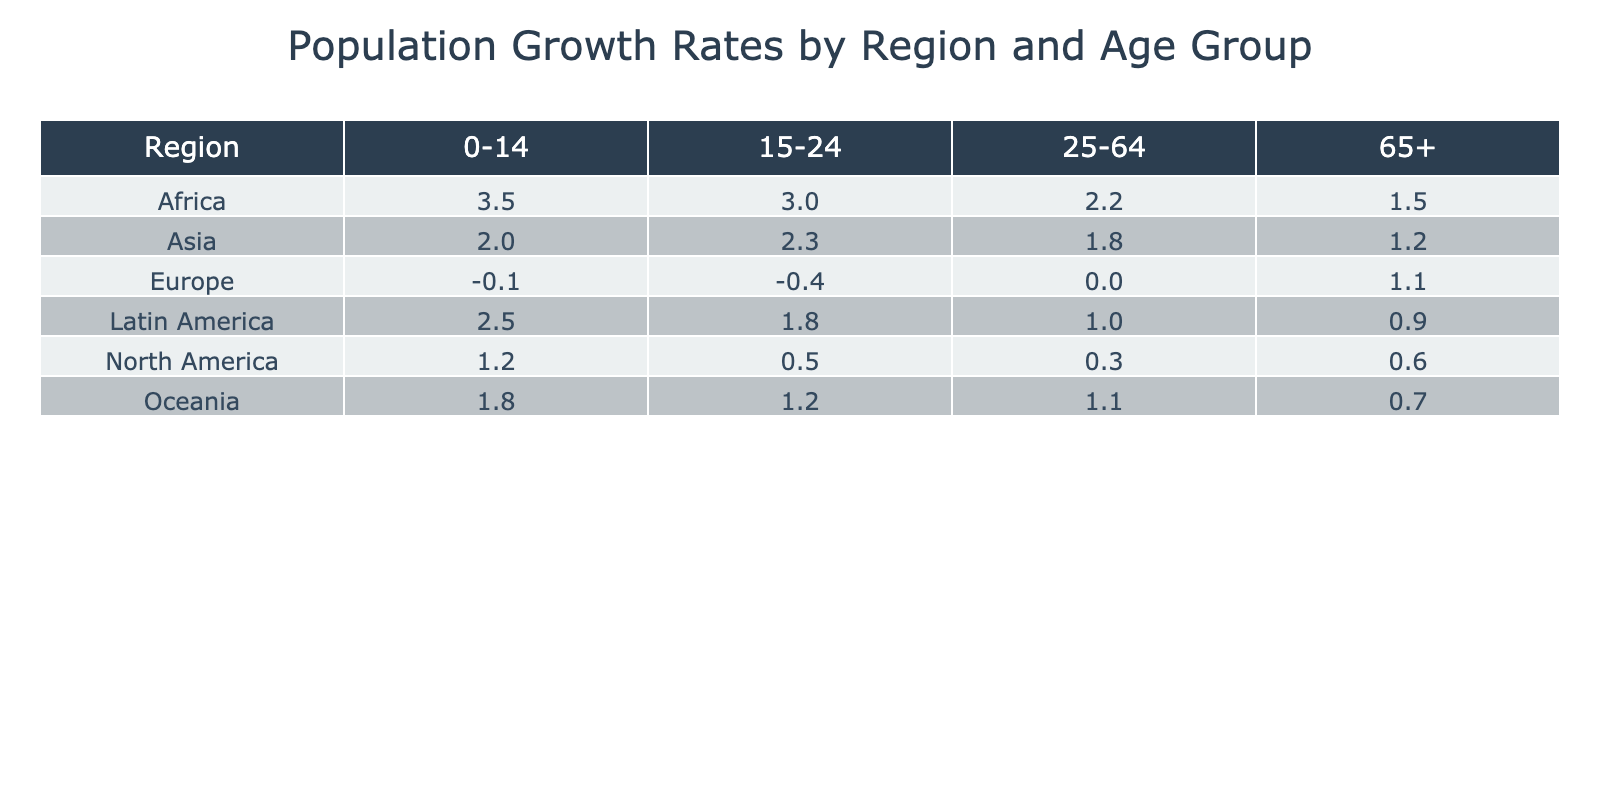What is the population growth rate for the age group 25-64 in North America? From the table, under the region North America and the age group 25-64, the corresponding value is 0.3%.
Answer: 0.3% Which region has the highest population growth rate for the age group 0-14? In the table, when checking the values for the age group 0-14, Africa has the highest rate at 3.5%.
Answer: Africa Is the population growth rate for the age group 65+ in Europe positive? Looking at the age group 65+ for Europe in the table, the value is 1.1%, which is indeed positive.
Answer: Yes What is the average population growth rate for the age group 15-24 across all regions? We first find the values for each region in the 15-24 age group: North America (0.5%), Latin America (1.8%), Europe (-0.4%), Asia (2.3%), Africa (3.0%), Oceania (1.2%). The sum is 0.5 + 1.8 - 0.4 + 2.3 + 3.0 + 1.2 = 8.4%. There are 6 regions, so the average is 8.4 / 6 = 1.4%.
Answer: 1.4% Which age group in Latin America has the lowest population growth rate? In Latin America, the age groups have the following rates: 0-14 (2.5%), 15-24 (1.8%), 25-64 (1.0%), and 65+ (0.9%). Comparing these values, the lowest is the age group 65+ at 0.9%.
Answer: 65+ 